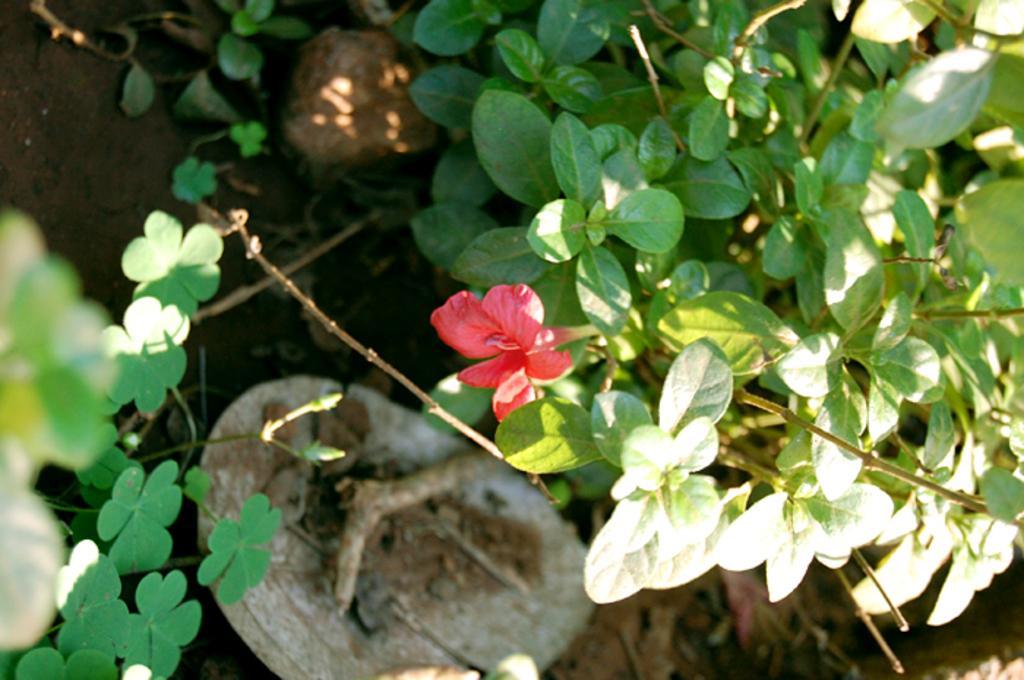Can you describe this image briefly? In this image we can see plant with red colored flower. 